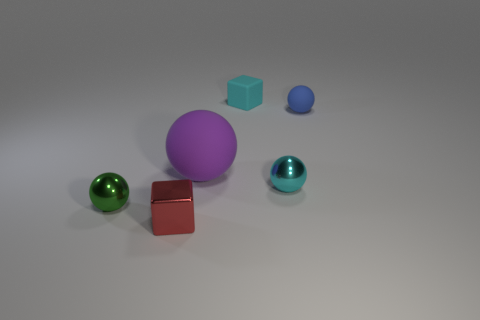There is a shiny thing that is the same color as the matte block; what shape is it?
Your answer should be compact. Sphere. How many cyan things are left of the cyan shiny ball?
Offer a very short reply. 1. There is a cyan object that is on the right side of the tiny cyan thing that is behind the small metal thing to the right of the cyan cube; what is its size?
Your response must be concise. Small. There is a purple matte thing; is it the same shape as the rubber object on the right side of the small matte block?
Your response must be concise. Yes. The blue ball that is made of the same material as the tiny cyan block is what size?
Your answer should be very brief. Small. Is there any other thing of the same color as the tiny matte block?
Your answer should be compact. Yes. What is the material of the small block that is in front of the tiny thing on the left side of the block that is to the left of the cyan matte object?
Offer a terse response. Metal. What number of matte things are either small blocks or large red cubes?
Your response must be concise. 1. Is the tiny shiny block the same color as the big object?
Offer a very short reply. No. Is there anything else that is made of the same material as the tiny cyan block?
Give a very brief answer. Yes. 